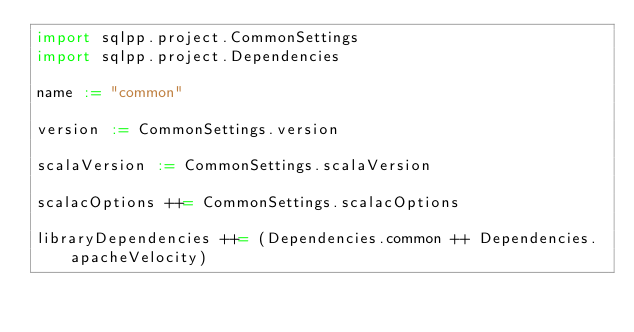Convert code to text. <code><loc_0><loc_0><loc_500><loc_500><_Scala_>import sqlpp.project.CommonSettings
import sqlpp.project.Dependencies

name := "common"

version := CommonSettings.version

scalaVersion := CommonSettings.scalaVersion

scalacOptions ++= CommonSettings.scalacOptions

libraryDependencies ++= (Dependencies.common ++ Dependencies.apacheVelocity)
</code> 